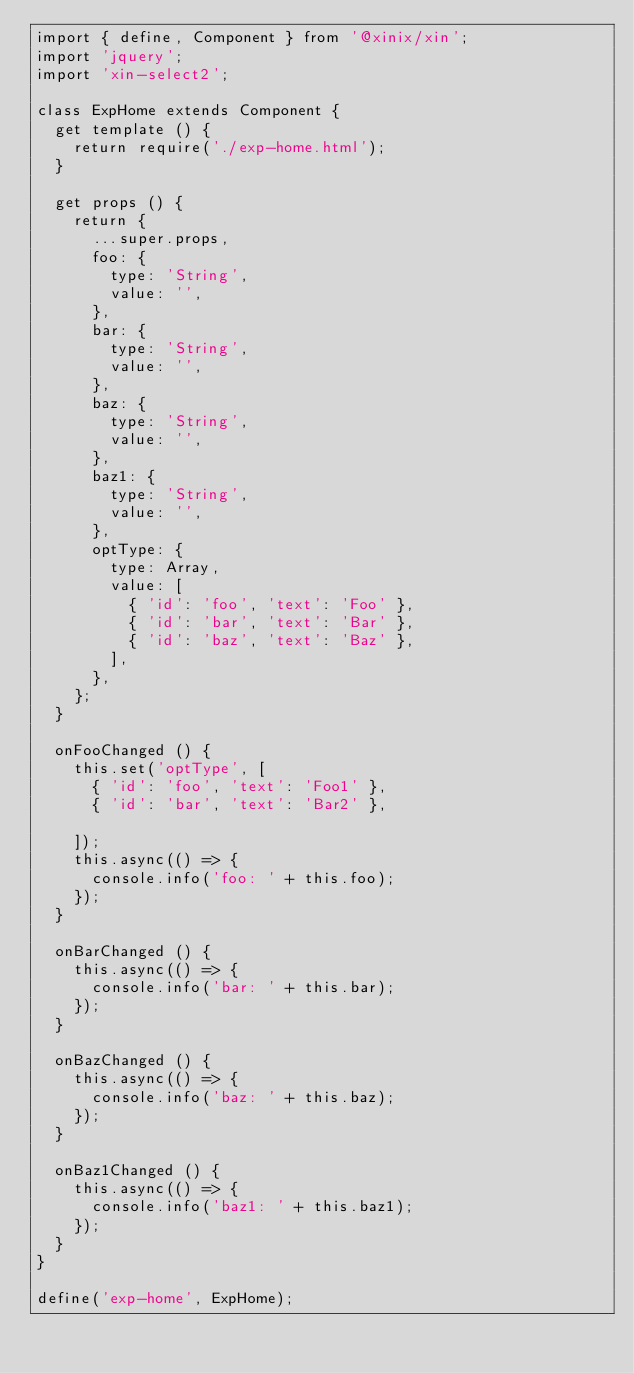Convert code to text. <code><loc_0><loc_0><loc_500><loc_500><_JavaScript_>import { define, Component } from '@xinix/xin';
import 'jquery';
import 'xin-select2';

class ExpHome extends Component {
  get template () {
    return require('./exp-home.html');
  }

  get props () {
    return {
      ...super.props,
      foo: {
        type: 'String',
        value: '',
      },
      bar: {
        type: 'String',
        value: '',
      },
      baz: {
        type: 'String',
        value: '',
      },
      baz1: {
        type: 'String',
        value: '',
      },
      optType: {
        type: Array,
        value: [
          { 'id': 'foo', 'text': 'Foo' },
          { 'id': 'bar', 'text': 'Bar' },
          { 'id': 'baz', 'text': 'Baz' },
        ],
      },
    };
  }

  onFooChanged () {
    this.set('optType', [
      { 'id': 'foo', 'text': 'Foo1' },
      { 'id': 'bar', 'text': 'Bar2' },

    ]);
    this.async(() => {
      console.info('foo: ' + this.foo);
    });
  }

  onBarChanged () {
    this.async(() => {
      console.info('bar: ' + this.bar);
    });
  }

  onBazChanged () {
    this.async(() => {
      console.info('baz: ' + this.baz);
    });
  }

  onBaz1Changed () {
    this.async(() => {
      console.info('baz1: ' + this.baz1);
    });
  }
}

define('exp-home', ExpHome);
</code> 